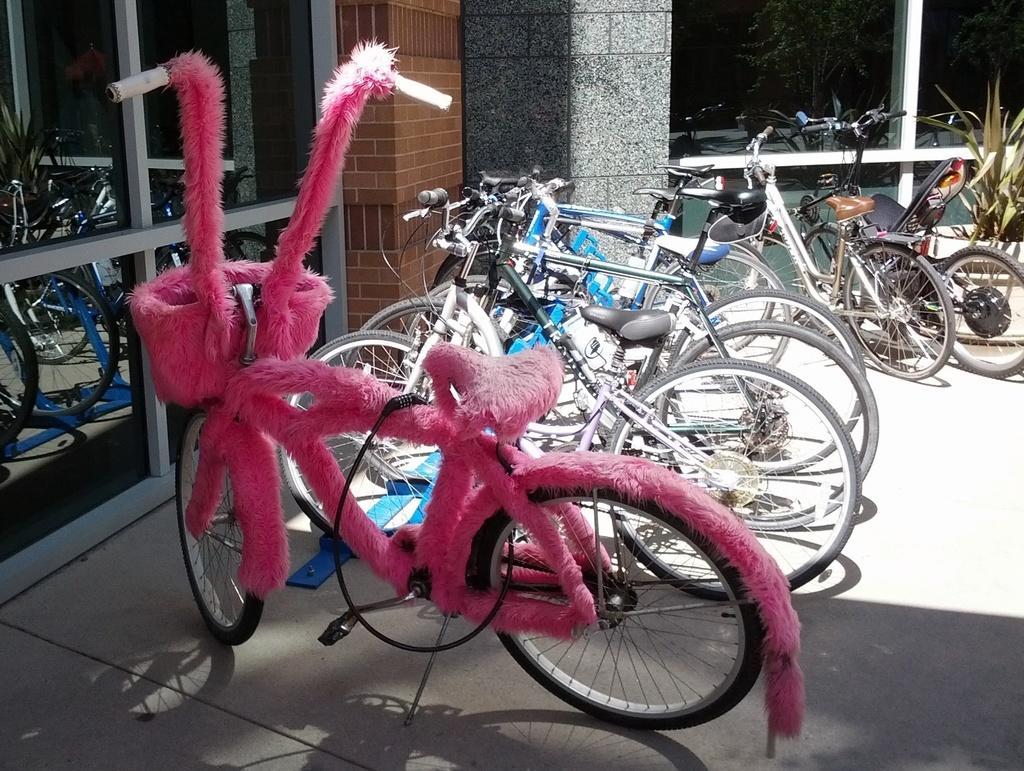Describe this image in one or two sentences. The picture is taken outside a store. In the center of the picture there are many bicycles. On the right there is a plant and glass window. On the left there is a glass window. In the center it is brick wall. It is sunny. 